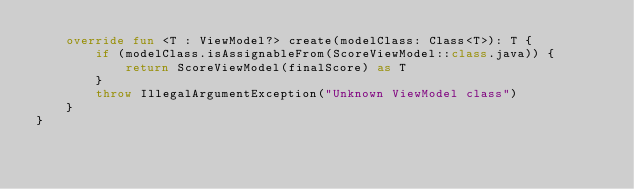<code> <loc_0><loc_0><loc_500><loc_500><_Kotlin_>    override fun <T : ViewModel?> create(modelClass: Class<T>): T {
        if (modelClass.isAssignableFrom(ScoreViewModel::class.java)) {
            return ScoreViewModel(finalScore) as T
        }
        throw IllegalArgumentException("Unknown ViewModel class")
    }
}</code> 